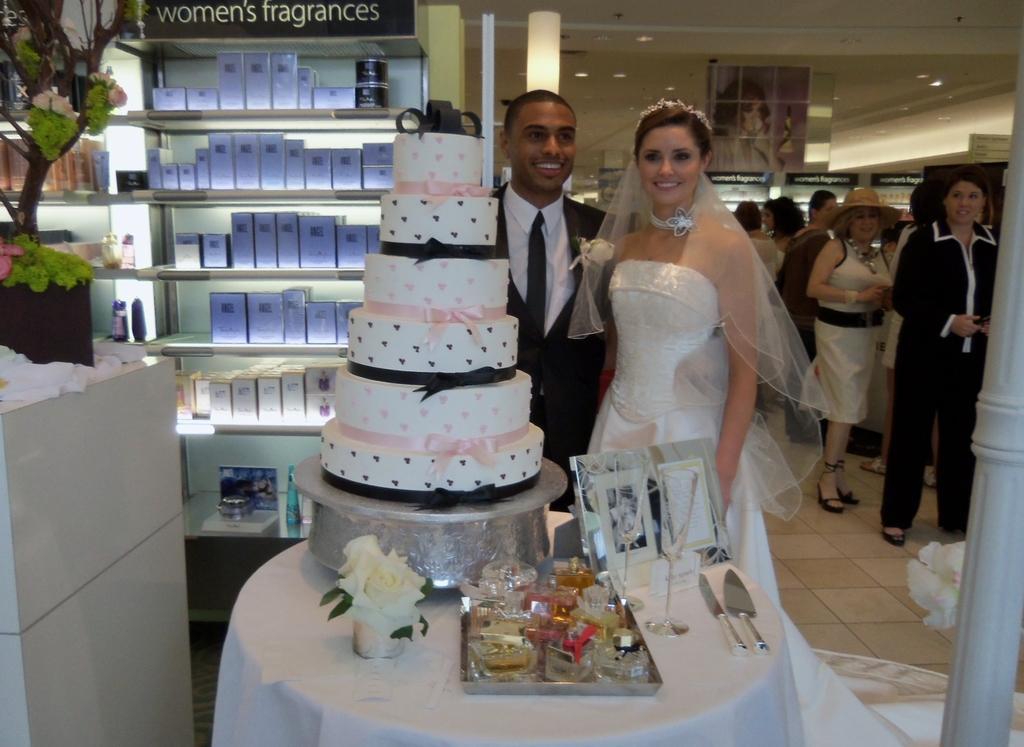Could you give a brief overview of what you see in this image? In this image in the front there is a table, on the table there are glasses, there is a cake and there are spoons, there is a photo frame and there is a flower. In the center there are persons standing and smiling. In the background there are group of persons standing and there is a shelf and on the shelf there are boxes and there is some text written on the top of the shelf. On the left side there is a plant in the pot and on the right side there is a pillar. 